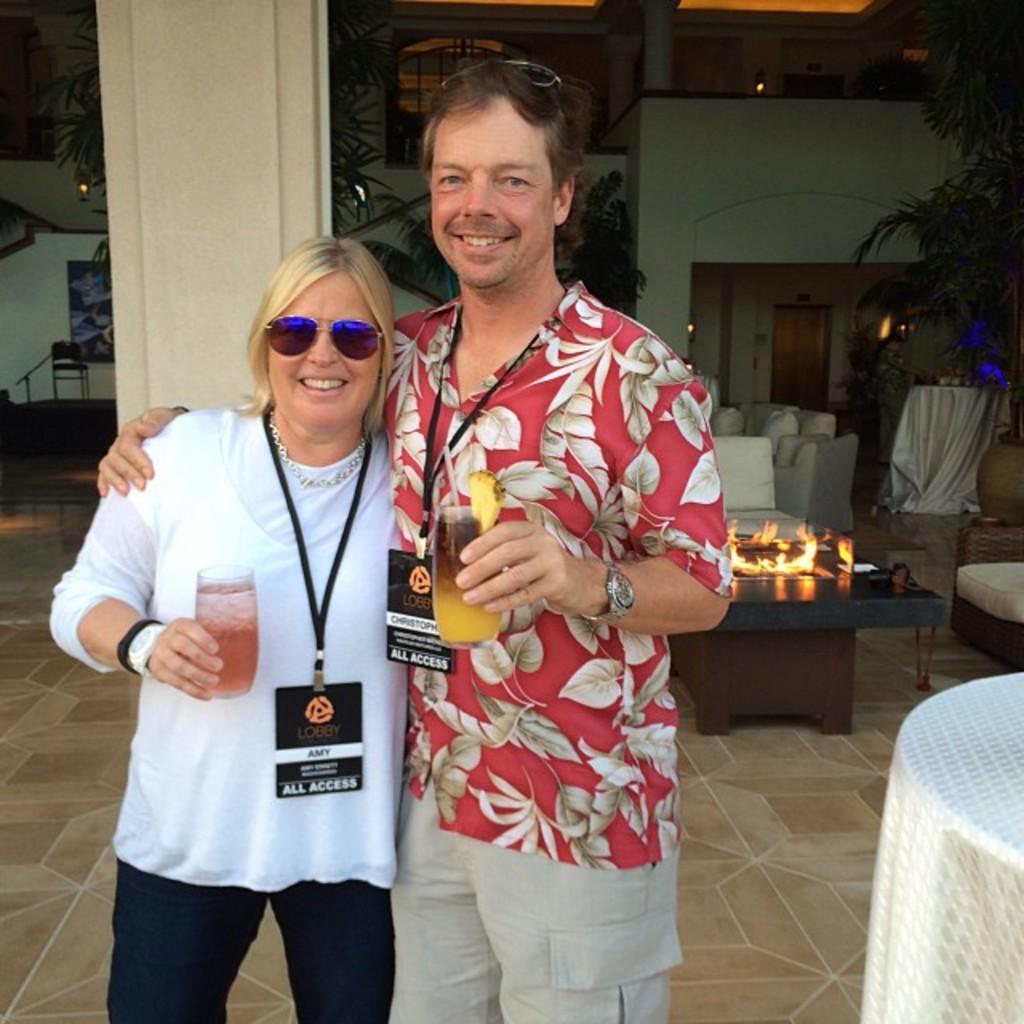Could you give a brief overview of what you see in this image? In this picture there is a man and woman standing and holding glasses in their hand. They are smiling and wearing identity card around their neck. In the image there are couches, tables and chairs. On one of the table there is fire. In the background there are doors, wall, pillars and plants. 